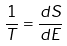<formula> <loc_0><loc_0><loc_500><loc_500>\frac { 1 } { T } = \frac { d S } { d E }</formula> 